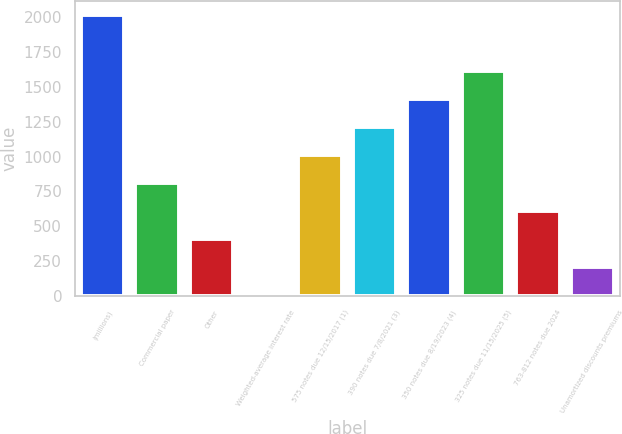Convert chart to OTSL. <chart><loc_0><loc_0><loc_500><loc_500><bar_chart><fcel>(millions)<fcel>Commercial paper<fcel>Other<fcel>Weighted-average interest rate<fcel>575 notes due 12/15/2017 (1)<fcel>390 notes due 7/8/2021 (3)<fcel>350 notes due 8/19/2023 (4)<fcel>325 notes due 11/15/2025 (5)<fcel>763-812 notes due 2024<fcel>Unamortized discounts premiums<nl><fcel>2017<fcel>808.18<fcel>405.24<fcel>2.3<fcel>1009.65<fcel>1211.12<fcel>1412.59<fcel>1614.06<fcel>606.71<fcel>203.77<nl></chart> 